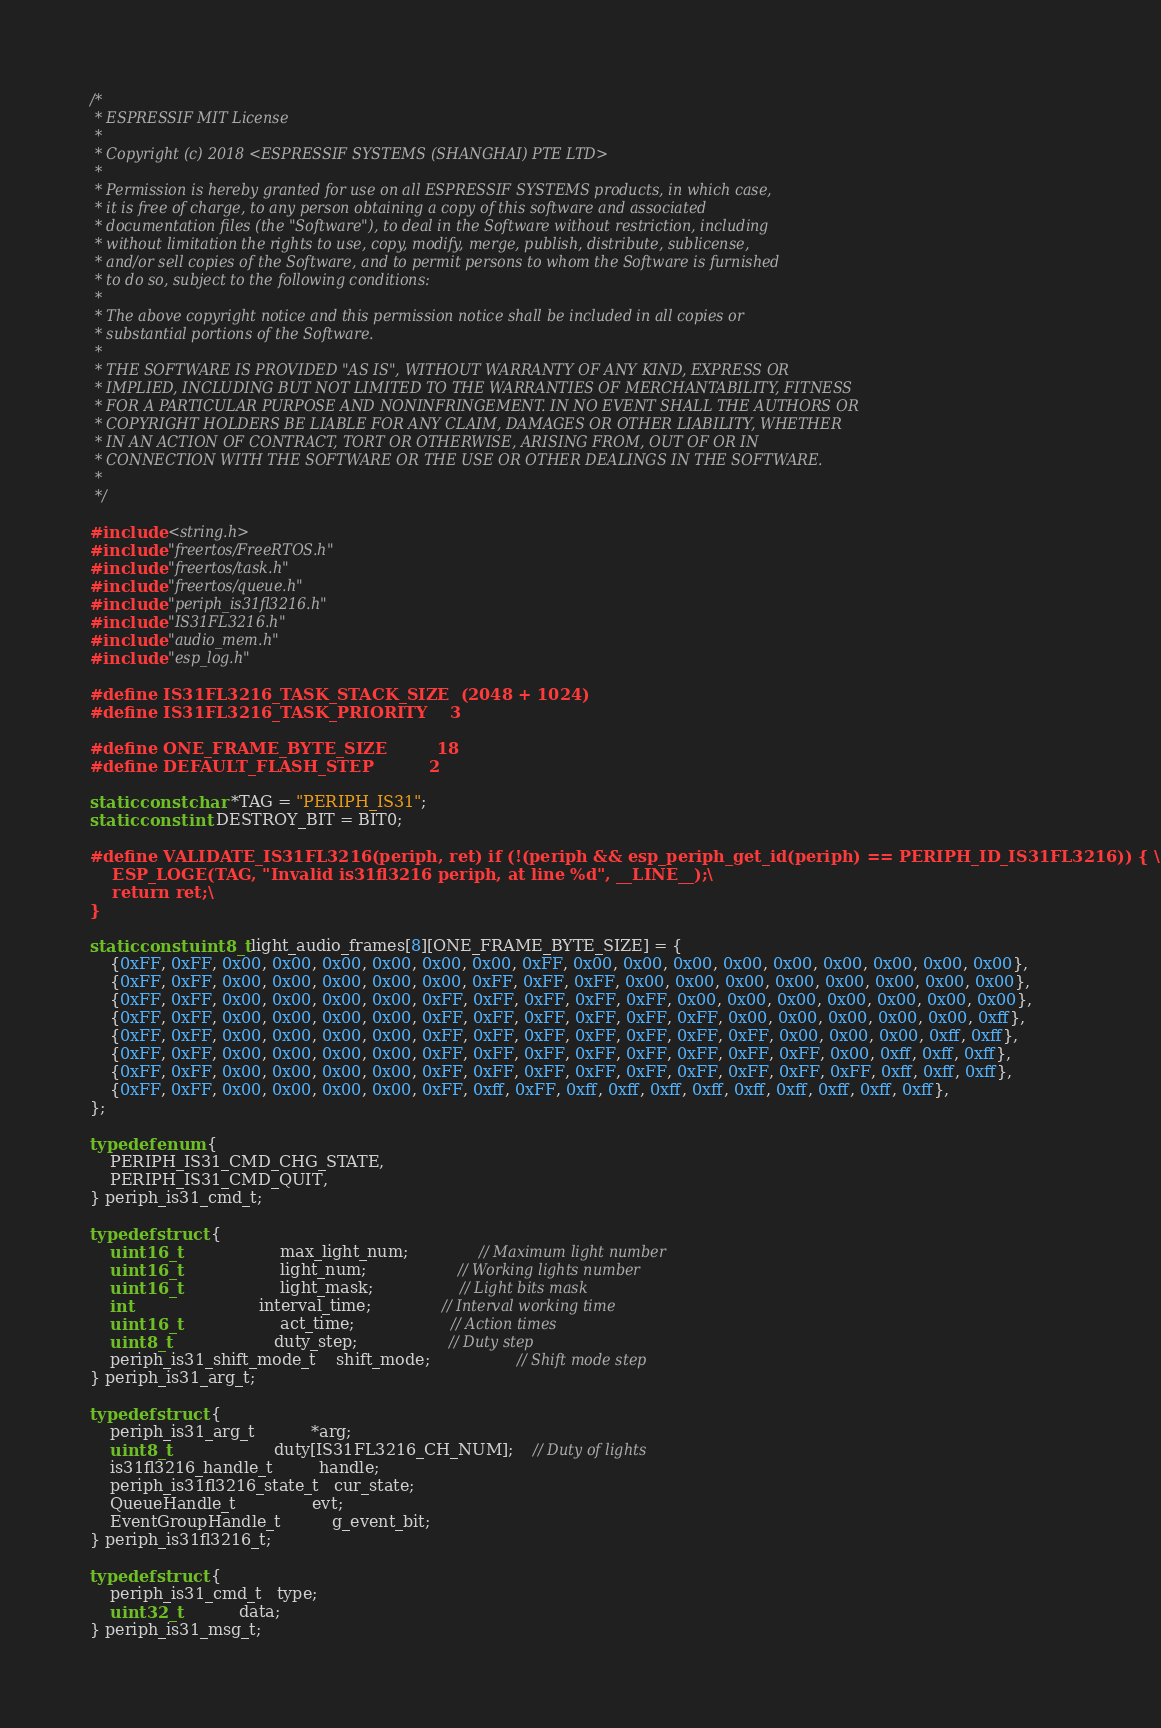Convert code to text. <code><loc_0><loc_0><loc_500><loc_500><_C_>/*
 * ESPRESSIF MIT License
 *
 * Copyright (c) 2018 <ESPRESSIF SYSTEMS (SHANGHAI) PTE LTD>
 *
 * Permission is hereby granted for use on all ESPRESSIF SYSTEMS products, in which case,
 * it is free of charge, to any person obtaining a copy of this software and associated
 * documentation files (the "Software"), to deal in the Software without restriction, including
 * without limitation the rights to use, copy, modify, merge, publish, distribute, sublicense,
 * and/or sell copies of the Software, and to permit persons to whom the Software is furnished
 * to do so, subject to the following conditions:
 *
 * The above copyright notice and this permission notice shall be included in all copies or
 * substantial portions of the Software.
 *
 * THE SOFTWARE IS PROVIDED "AS IS", WITHOUT WARRANTY OF ANY KIND, EXPRESS OR
 * IMPLIED, INCLUDING BUT NOT LIMITED TO THE WARRANTIES OF MERCHANTABILITY, FITNESS
 * FOR A PARTICULAR PURPOSE AND NONINFRINGEMENT. IN NO EVENT SHALL THE AUTHORS OR
 * COPYRIGHT HOLDERS BE LIABLE FOR ANY CLAIM, DAMAGES OR OTHER LIABILITY, WHETHER
 * IN AN ACTION OF CONTRACT, TORT OR OTHERWISE, ARISING FROM, OUT OF OR IN
 * CONNECTION WITH THE SOFTWARE OR THE USE OR OTHER DEALINGS IN THE SOFTWARE.
 *
 */

#include <string.h>
#include "freertos/FreeRTOS.h"
#include "freertos/task.h"
#include "freertos/queue.h"
#include "periph_is31fl3216.h"
#include "IS31FL3216.h"
#include "audio_mem.h"
#include "esp_log.h"

#define IS31FL3216_TASK_STACK_SIZE  (2048 + 1024)
#define IS31FL3216_TASK_PRIORITY    3

#define ONE_FRAME_BYTE_SIZE         18
#define DEFAULT_FLASH_STEP          2

static const char *TAG = "PERIPH_IS31";
static const int DESTROY_BIT = BIT0;

#define VALIDATE_IS31FL3216(periph, ret) if (!(periph && esp_periph_get_id(periph) == PERIPH_ID_IS31FL3216)) { \
    ESP_LOGE(TAG, "Invalid is31fl3216 periph, at line %d", __LINE__);\
    return ret;\
}

static const uint8_t light_audio_frames[8][ONE_FRAME_BYTE_SIZE] = {
    {0xFF, 0xFF, 0x00, 0x00, 0x00, 0x00, 0x00, 0x00, 0xFF, 0x00, 0x00, 0x00, 0x00, 0x00, 0x00, 0x00, 0x00, 0x00},
    {0xFF, 0xFF, 0x00, 0x00, 0x00, 0x00, 0x00, 0xFF, 0xFF, 0xFF, 0x00, 0x00, 0x00, 0x00, 0x00, 0x00, 0x00, 0x00},
    {0xFF, 0xFF, 0x00, 0x00, 0x00, 0x00, 0xFF, 0xFF, 0xFF, 0xFF, 0xFF, 0x00, 0x00, 0x00, 0x00, 0x00, 0x00, 0x00},
    {0xFF, 0xFF, 0x00, 0x00, 0x00, 0x00, 0xFF, 0xFF, 0xFF, 0xFF, 0xFF, 0xFF, 0x00, 0x00, 0x00, 0x00, 0x00, 0xff},
    {0xFF, 0xFF, 0x00, 0x00, 0x00, 0x00, 0xFF, 0xFF, 0xFF, 0xFF, 0xFF, 0xFF, 0xFF, 0x00, 0x00, 0x00, 0xff, 0xff},
    {0xFF, 0xFF, 0x00, 0x00, 0x00, 0x00, 0xFF, 0xFF, 0xFF, 0xFF, 0xFF, 0xFF, 0xFF, 0xFF, 0x00, 0xff, 0xff, 0xff},
    {0xFF, 0xFF, 0x00, 0x00, 0x00, 0x00, 0xFF, 0xFF, 0xFF, 0xFF, 0xFF, 0xFF, 0xFF, 0xFF, 0xFF, 0xff, 0xff, 0xff},
    {0xFF, 0xFF, 0x00, 0x00, 0x00, 0x00, 0xFF, 0xff, 0xFF, 0xff, 0xff, 0xff, 0xff, 0xff, 0xff, 0xff, 0xff, 0xff},
};

typedef enum {
    PERIPH_IS31_CMD_CHG_STATE,
    PERIPH_IS31_CMD_QUIT,
} periph_is31_cmd_t;

typedef struct {
    uint16_t                    max_light_num;              // Maximum light number
    uint16_t                    light_num;                  // Working lights number
    uint16_t                    light_mask;                 // Light bits mask
    int                         interval_time;              // Interval working time
    uint16_t                    act_time;                   // Action times
    uint8_t                     duty_step;                  // Duty step
    periph_is31_shift_mode_t    shift_mode;                 // Shift mode step
} periph_is31_arg_t;

typedef struct {
    periph_is31_arg_t           *arg;
    uint8_t                     duty[IS31FL3216_CH_NUM];    // Duty of lights
    is31fl3216_handle_t         handle;
    periph_is31fl3216_state_t   cur_state;
    QueueHandle_t               evt;
    EventGroupHandle_t          g_event_bit;
} periph_is31fl3216_t;

typedef struct {
    periph_is31_cmd_t   type;
    uint32_t            data;
} periph_is31_msg_t;
</code> 